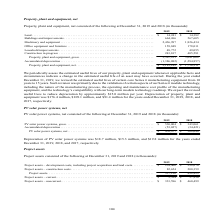According to First Solar's financial document, What were the reasons for the revision of manufacturing equipment in 2019? Such revision was primarily due to the validation of certain aspects of our Series 6 module technology, including the nature of the manufacturing process, the operating and maintenance cost profile of the manufacturing equipment, and the technology’s compatibility with our long-term module technology roadmap.. The document states: "manufacturing equipment from 10 years to 15 years. Such revision was primarily due to the validation of certain aspects of our Series 6 module technol..." Also, How much will depreciation expense decrease as a result of the revision in useful life? reduce depreciation by approximately $15.0 million per year. The document states: "gy roadmap. We expect the revised useful lives to reduce depreciation by approximately $15.0 million per year. Depreciation of property, plant and equ..." Also, What was the depreciation of property, plant and equipment in 2019?  According to the financial document, $176.4 million. The relevant text states: "Depreciation of property, plant and equipment was $176.4 million, $109.1 million, and $91.4 million for the years ended December 31, 2019, 2018, and 2017, respectiv..." Also, can you calculate: What was the increase in machinery and equipment from 2018 to 2019? Based on the calculation: 2,436,997 - 1,826,434 , the result is 610563 (in thousands). This is based on the information: "ments . 664,266 567,605 Machinery and equipment . 2,436,997 1,826,434 Office equipment and furniture . 159,848 178,011 Leasehold improvements . 48,772 49,055 C 4,266 567,605 Machinery and equipment . ..." The key data points involved are: 1,826,434, 2,436,997. Also, can you calculate: What is the difference between land from 2018 to 2019? Based on the calculation: 14,241 - 14,382 , the result is -141 (in thousands). This is based on the information: "2019 2018 Land . $ 14,241 $ 14,382 Buildings and improvements . 664,266 567,605 Machinery and equipment . 2,436,997 1,826,434 Office e 2019 2018 Land . $ 14,241 $ 14,382 Buildings and improvements . 6..." The key data points involved are: 14,241, 14,382. Also, can you calculate: What is the percentage increase in net property, plant and equipment from 2018 to 2019? To answer this question, I need to perform calculations using the financial data. The calculation is: (2,181,149 - 1,756,211)/1,756,211 , which equals 24.2 (percentage). This is based on the information: "roperty, plant and equipment, net . $ 2,181,149 $ 1,756,211 1,284,857) Property, plant and equipment, net . $ 2,181,149 $ 1,756,211..." The key data points involved are: 1,756,211, 2,181,149. 